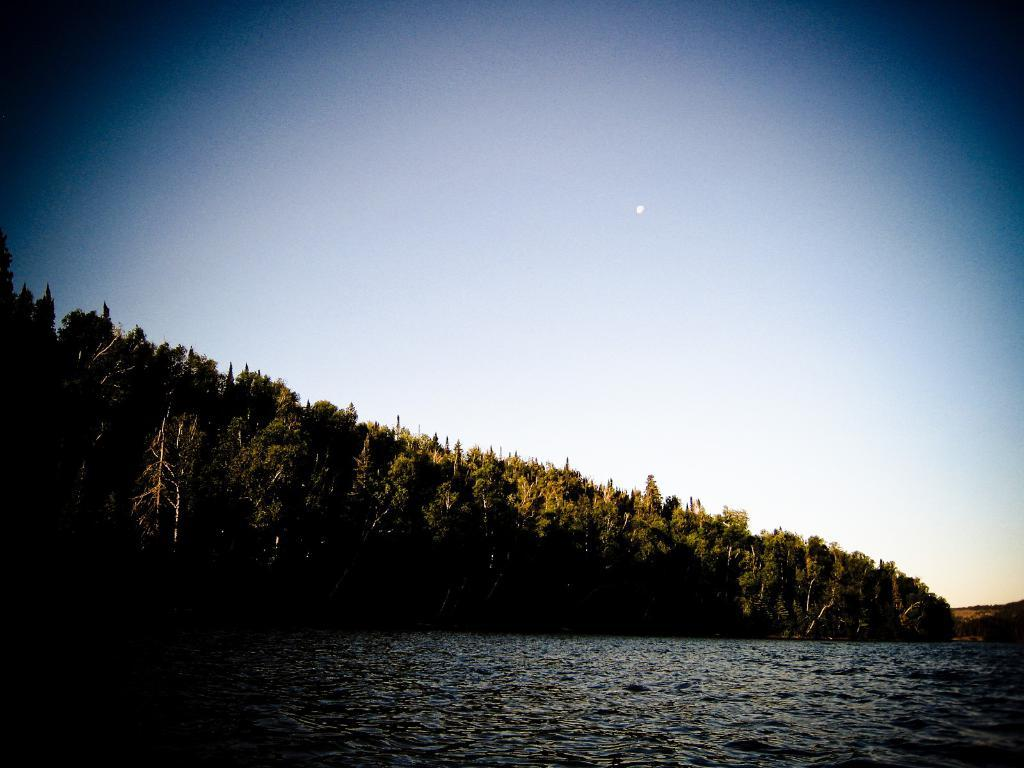What type of vegetation can be seen in the image? There are trees in the image. What natural element is visible in the image besides the trees? There is water visible in the image. What can be seen in the background of the image? The sky is visible in the background of the image. How many cabbages are floating in the ocean in the image? There is no ocean or cabbages present in the image; it features trees and water. 